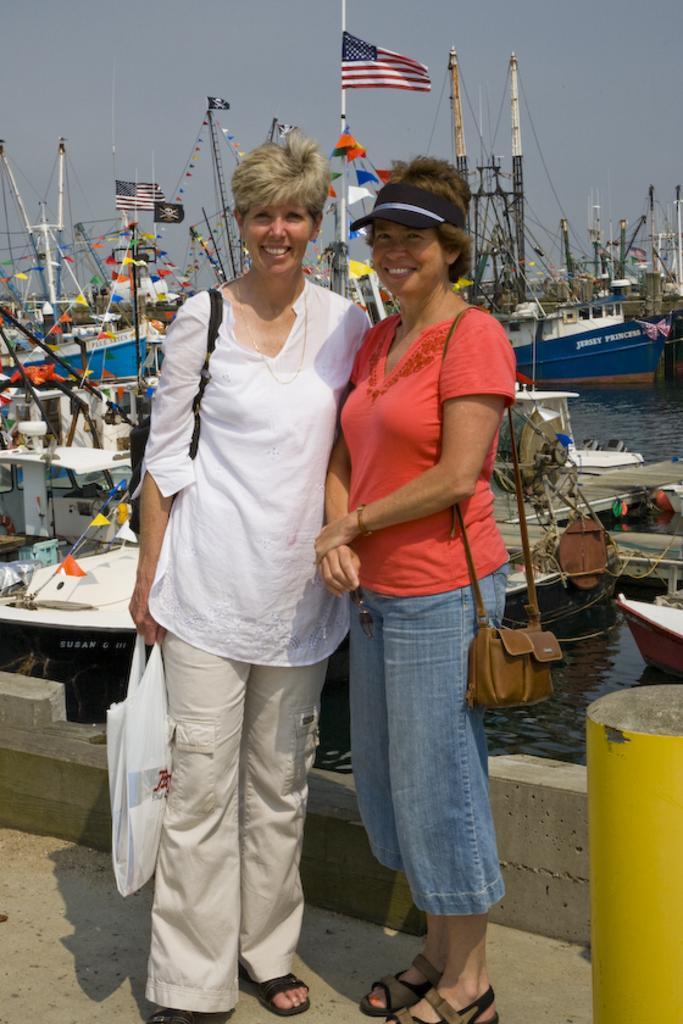Could you give a brief overview of what you see in this image? In this image, we can see two women are standing. They are watching and smiling. They are wearing bags. Here a woman is carrying a carry bag. Background we can see few boats are above the water. Right side bottom corner, we can see yellow color pole. Top of the image, there is a sky. Here we can see few flags and paper crafts. 